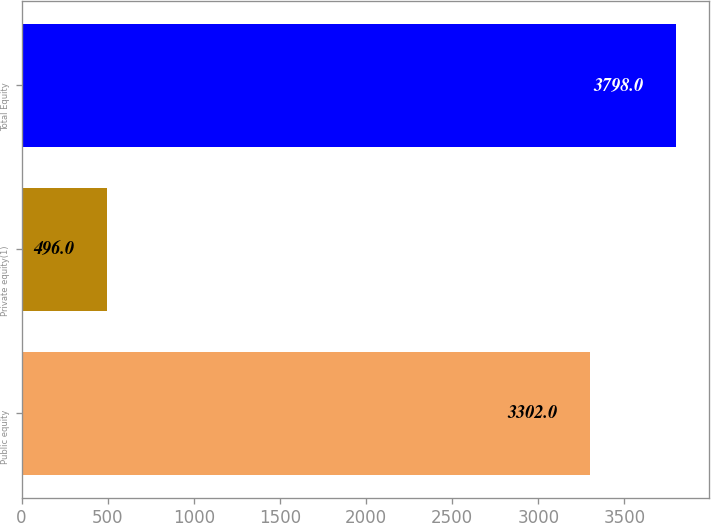Convert chart. <chart><loc_0><loc_0><loc_500><loc_500><bar_chart><fcel>Public equity<fcel>Private equity(1)<fcel>Total Equity<nl><fcel>3302<fcel>496<fcel>3798<nl></chart> 